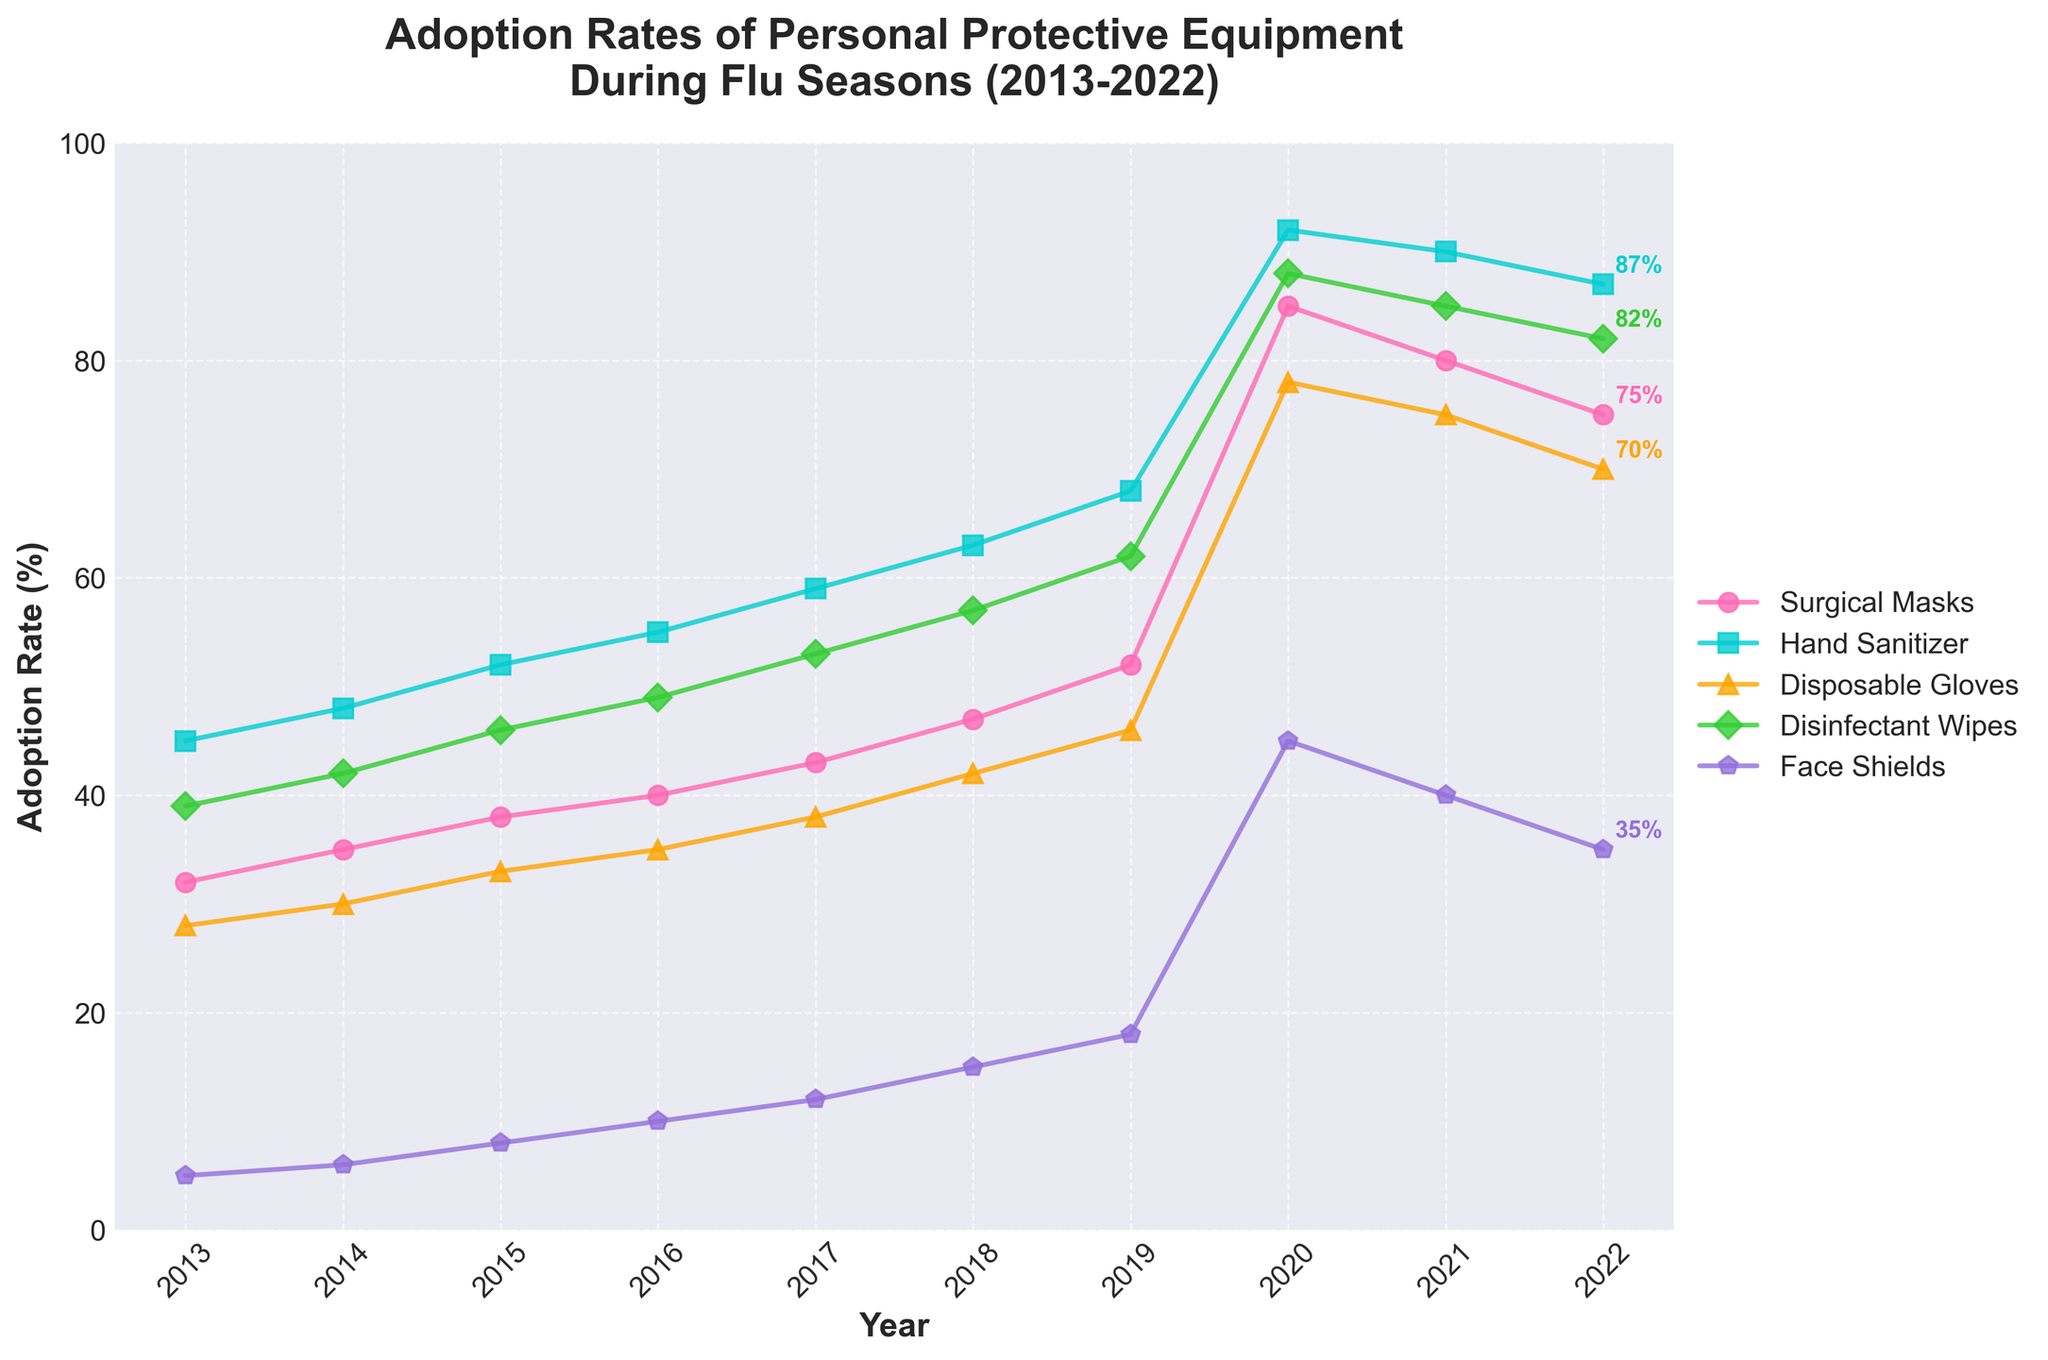Which type of personal protective equipment had the highest adoption rate in 2020? The figure shows five types of personal protective equipment with their adoption rates over the years. In 2020, Surgical Masks had the highest adoption rate of 85%.
Answer: Surgical Masks How did the adoption rate of Disinfectant Wipes change from 2019 to 2020? In 2019, the adoption rate for Disinfectant Wipes was 62%. In 2020, it increased to 88%. Thus, the change is 88% - 62% = 26%
Answer: Increased by 26% What is the trend in the adoption rate of Face Shields between 2013 and 2022? The data shows a continuous increase from 5% in 2013 to 35% in 2022, with a significant surge in 2020 at 45%. Post-2020, there is a slight decline.
Answer: Increasing with a peak in 2020, then a slight decline Compare the adoption rates of Hand Sanitizer and Disposable Gloves in 2017. Which was higher, and by how much? In 2017, adoption rate for Hand Sanitizer was 59%, while for Disposable Gloves it was 38%. The difference is 59% - 38% = 21%.
Answer: Hand Sanitizer by 21% What was the average adoption rate of Surgical Masks from 2013 to 2022? Sum the adoption rates from 2013 to 2022 and divide by the number of years: (32 + 35 + 38 + 40 + 43 + 47 + 52 + 85 + 80 + 75) / 10 = 52.7%
Answer: 52.7% Which year saw the highest combined adoption rate of all PPE types? Sum the adoption rates for each year and compare: 2020 has the highest combined rate with Surgical Masks (85) + Hand Sanitizer (92) + Disposable Gloves (78) + Disinfectant Wipes (88) + Face Shields (45) = 388
Answer: 2020 What was the difference in the adoption rate of Hand Sanitizer between 2015 and 2021? The adoption rate in 2015 was 52% and in 2021 it was 90%. The difference is 90% - 52% = 38%.
Answer: 38% From 2019 to 2021, which PPE showed the largest increase in adoption rate? Compare the increase for each PPE from 2019 to 2021: Surgical Masks (85 - 52 = 33), Hand Sanitizer (92 - 68 = 24), Disposable Gloves (78 - 46 = 32), Disinfectant Wipes (88 - 62 = 26), Face Shields (45 - 18 = 27). The largest increase is in Disposable Gloves at 32%.
Answer: Disposable Gloves What visual characteristic identifies the trend of Surgical Masks' adoption rates over the years? The trend for Surgical Masks is shown by the pink line with circles as markers that consistently increases until 2020, peaks, and then slightly declines.
Answer: Pink line with circles Approximately what percentage adoption rate does the chart show for Disposable Gloves in 2022? Locate the 2022 data point for the green line with triangles, marking Disposable Gloves, which shows around 70%.
Answer: 70% 